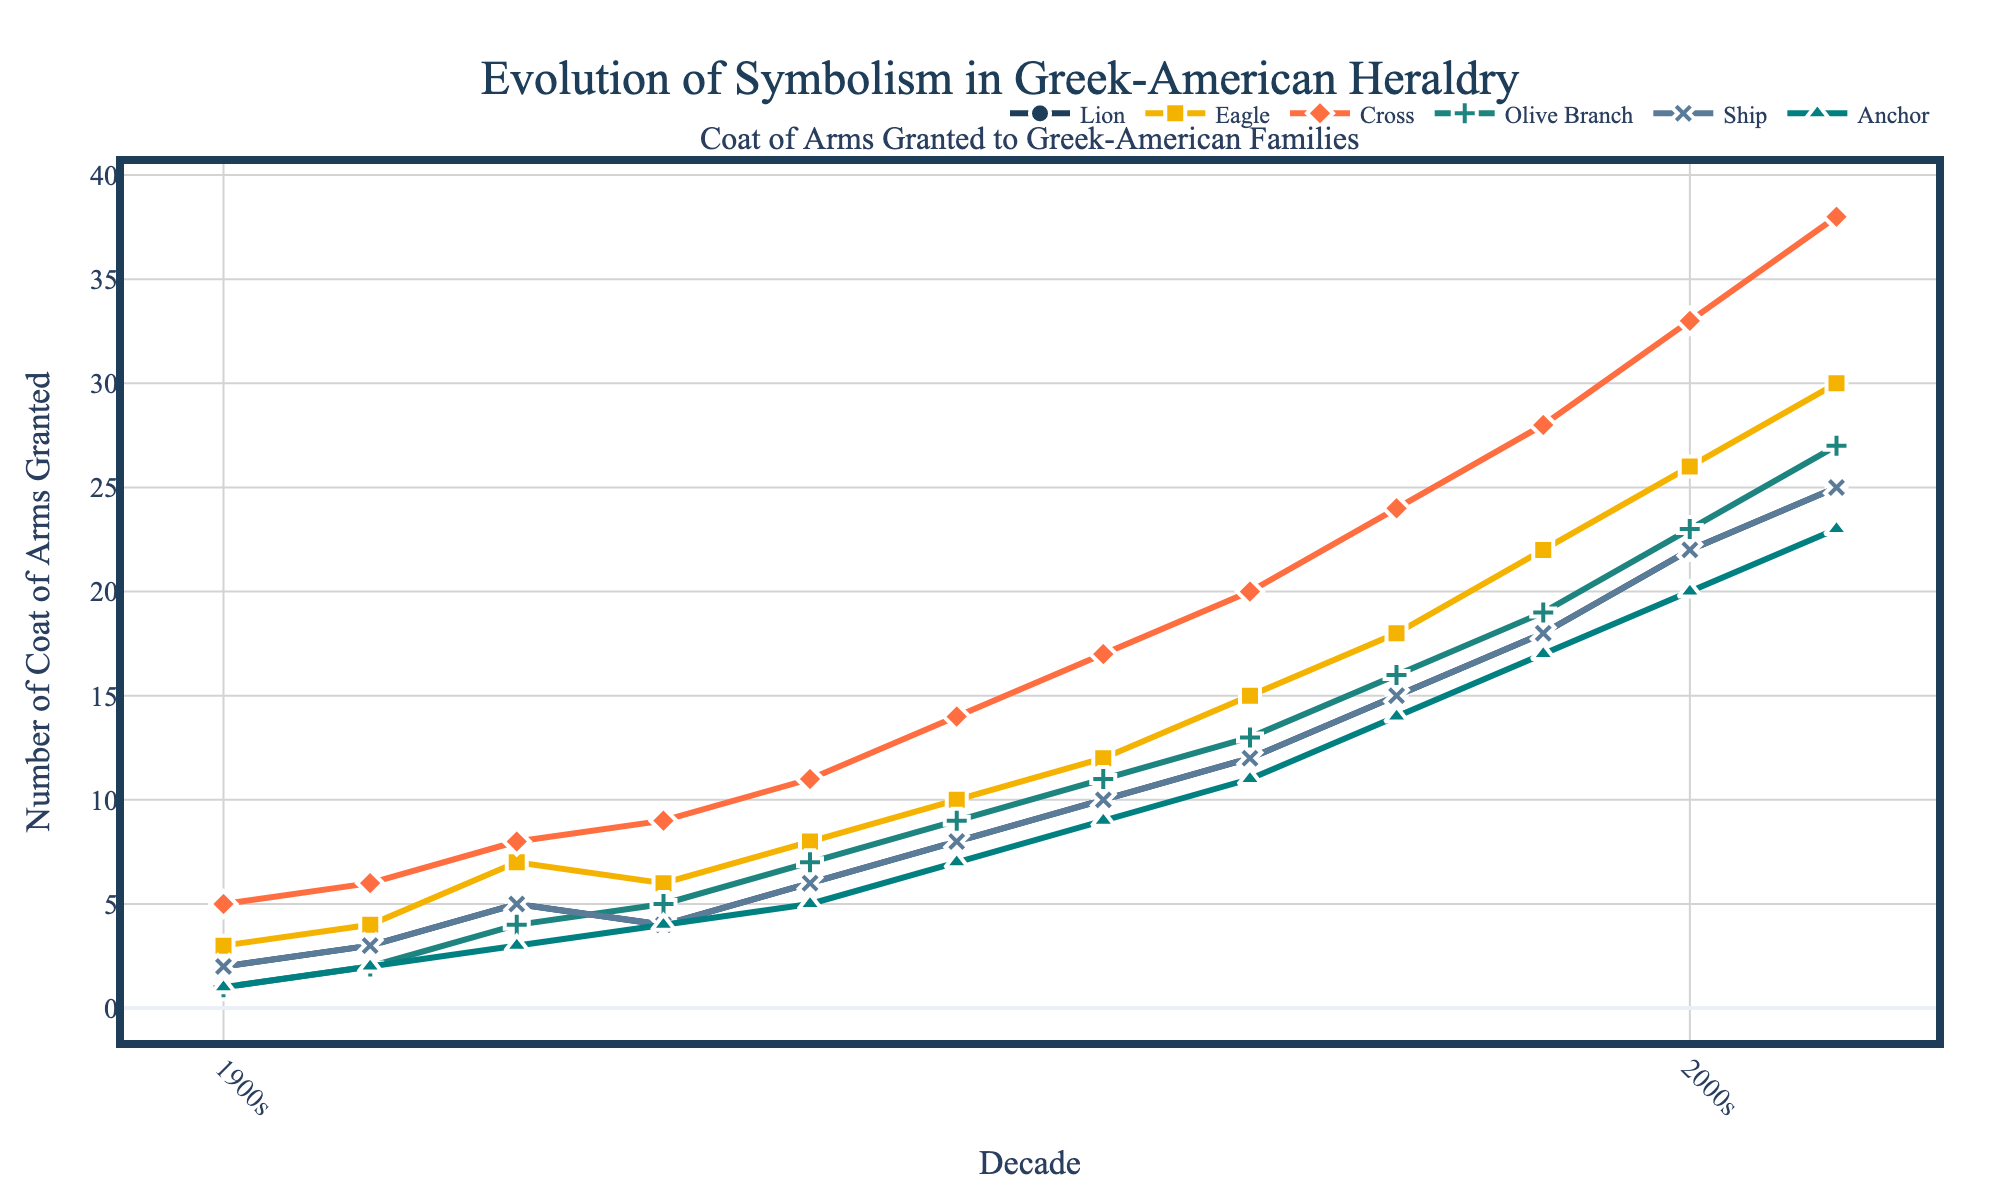Which decade saw the highest number of crosses granted in Greek-American coats of arms? Look at the line representing "Cross" and identify the peak point. The highest peak occurs in the 2010s.
Answer: 2010s How many coats of arms with anchors were granted in total from the 1940s to the 1980s? Sum the number of anchors granted over each decade from the 1940s to the 1980s: 5 (1940s) + 7 (1950s) + 9 (1960s) + 11 (1970s) + 14 (1980s) = 46.
Answer: 46 By how much did the number of olive branches increase from the 1930s to the 2000s? Subtract the number of olive branches in the 1930s (5) from the number in the 2000s (23): 23 - 5 = 18.
Answer: 18 In which decade did ships overtake olive branches in the number of coats of arms? Find the decade where the number of ships first exceeds the number of olive branches. Ships (13) overtook olive branches (11) in the 1970s.
Answer: 1970s What was the average number of lions granted in the 1960s and 1970s? Calculate the average: (10 in the 1960s + 12 in the 1970s) / 2 = 22 / 2 = 11.
Answer: 11 Which symbol had the least number of coats of arms in the 1910s? Compare the numbers in the 1910s: Lions (3), Eagles (4), Crosses (6), Olive Branches (2), Ships (3), Anchors (2). The Olive Branch and Anchor both have the least, which is 2.
Answer: Olive Branches and Anchors What is the combined total of coats of arms with ships and anchors in the 2000s? Add the number of ships and anchors in the 2000s: Ships (22) + Anchors (20) = 42.
Answer: 42 